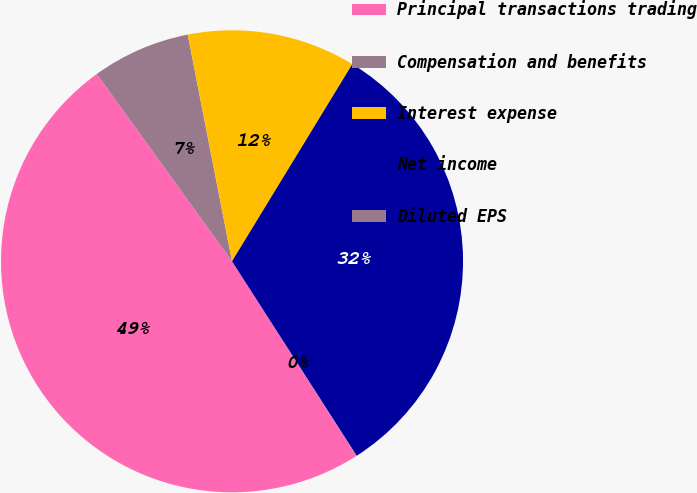Convert chart. <chart><loc_0><loc_0><loc_500><loc_500><pie_chart><fcel>Principal transactions trading<fcel>Compensation and benefits<fcel>Interest expense<fcel>Net income<fcel>Diluted EPS<nl><fcel>49.09%<fcel>6.88%<fcel>11.79%<fcel>32.21%<fcel>0.03%<nl></chart> 